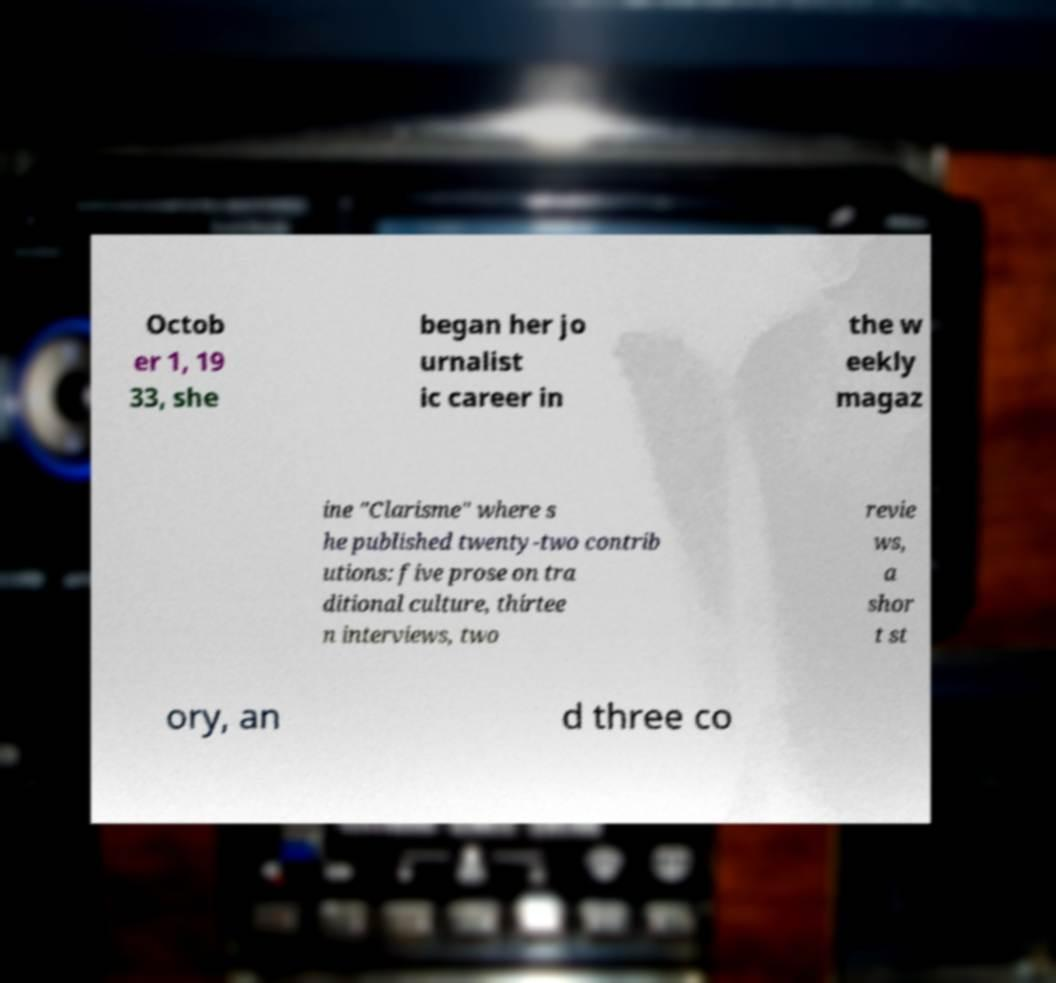Can you accurately transcribe the text from the provided image for me? Octob er 1, 19 33, she began her jo urnalist ic career in the w eekly magaz ine "Clarisme" where s he published twenty-two contrib utions: five prose on tra ditional culture, thirtee n interviews, two revie ws, a shor t st ory, an d three co 